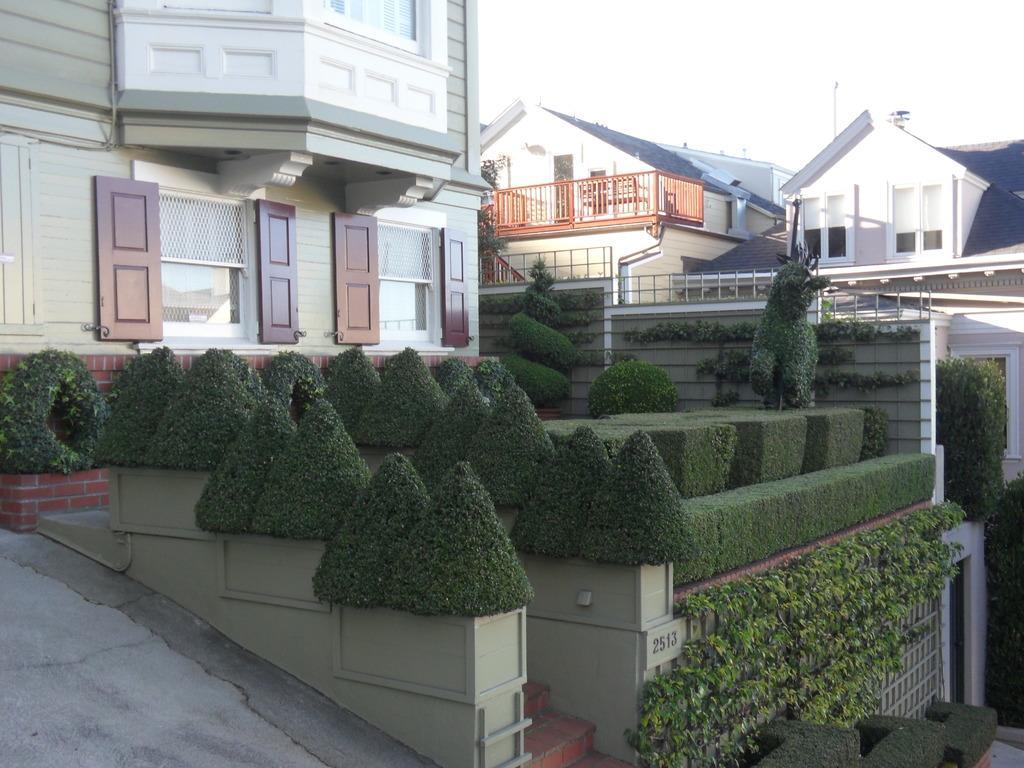Please provide a concise description of this image. In this image I see houses and I see bushes and on this board I see the numbers and I see the steps and the path over here. In the background I see the sky. 